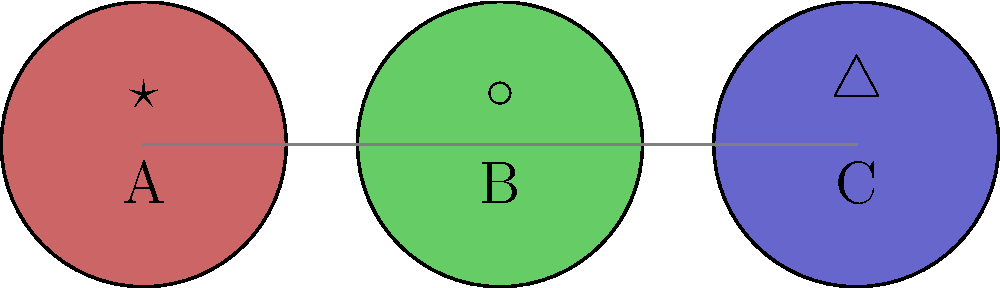In a series of celestial-themed sculptures, three pieces are arranged linearly and connected by conceptual threads. Sculpture A is associated with a star symbol, B with a circle, and C with a triangle. What could this progression symbolize in the context of extraterrestrial exploration? To interpret this symbolism, let's analyze the progression step-by-step:

1. Sculpture A (Star symbol ★):
   - Stars are often associated with distant celestial bodies and the vastness of space.
   - In the context of extraterrestrial exploration, this could represent the initial phase of observing distant worlds.

2. Sculpture B (Circle symbol ○):
   - Circles often symbolize wholeness, unity, or planets.
   - This could represent the phase of identifying and focusing on specific celestial bodies of interest.

3. Sculpture C (Triangle symbol △):
   - Triangles are often associated with direction, ascension, or human-made structures.
   - In this context, it could symbolize active exploration or even colonization efforts.

4. The progression from A to C:
   - The arrangement suggests a linear narrative or evolution in extraterrestrial exploration.
   - It moves from distant observation (stars) to identifying specific targets (planets) to active exploration or interaction (human intervention).

5. The connecting lines:
   - These suggest a continuous, interconnected process linking each phase of exploration.

Given the artist's focus on extraterrestrial themes and the curator's interest in this aspect, the most likely interpretation is that this series symbolizes the stages of human exploration of space: from initial observation of stars, to identification of potential planetary targets, to active exploration or colonization efforts.
Answer: Stages of space exploration 